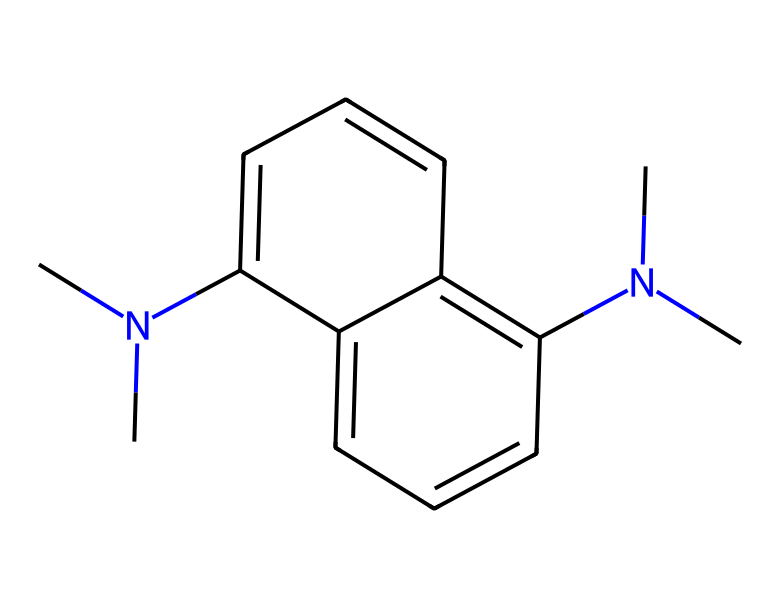What is the main functional group present in this structure? The structure contains multiple nitrogen atoms, indicating the presence of amine functional groups. These nitrogen atoms can indicate basic properties and participation in reactions characteristic of superbases.
Answer: amine How many aromatic rings are present in this chemical? By analyzing the SMILES, it can be observed that there are two fused aromatic rings in the structure, which can be confirmed by their connectivity shown in the SMILES representation.
Answer: two What type of base is this chemical classified as? Given its structure and presence of nitrogen atoms, this chemical is classified as a superbase, which typically contains basic nitrogen functionalities that can abstract protons very effectively.
Answer: superbase How many methyl groups are linked to the nitrogen atoms in this structure? The structure shows that there are two nitrogen atoms, each of which is connected to a methyl group, leading to a total of two methyl groups in this structure.
Answer: two Which feature in the structure contributes to its proton-accepting ability? The presence of the two lone pairs on the nitrogen atoms in the amine groups offers sites for protonation, thereby contributing to the molecule's efficiency as a proton sponge.
Answer: lone pairs What is the role of this chemical in studying marble weathering? This chemical can be used as a proton sponge to easily absorb protons from acidic conditions, facilitating the study of marble and carbonate rock weathering under acidic environments.
Answer: proton sponge 